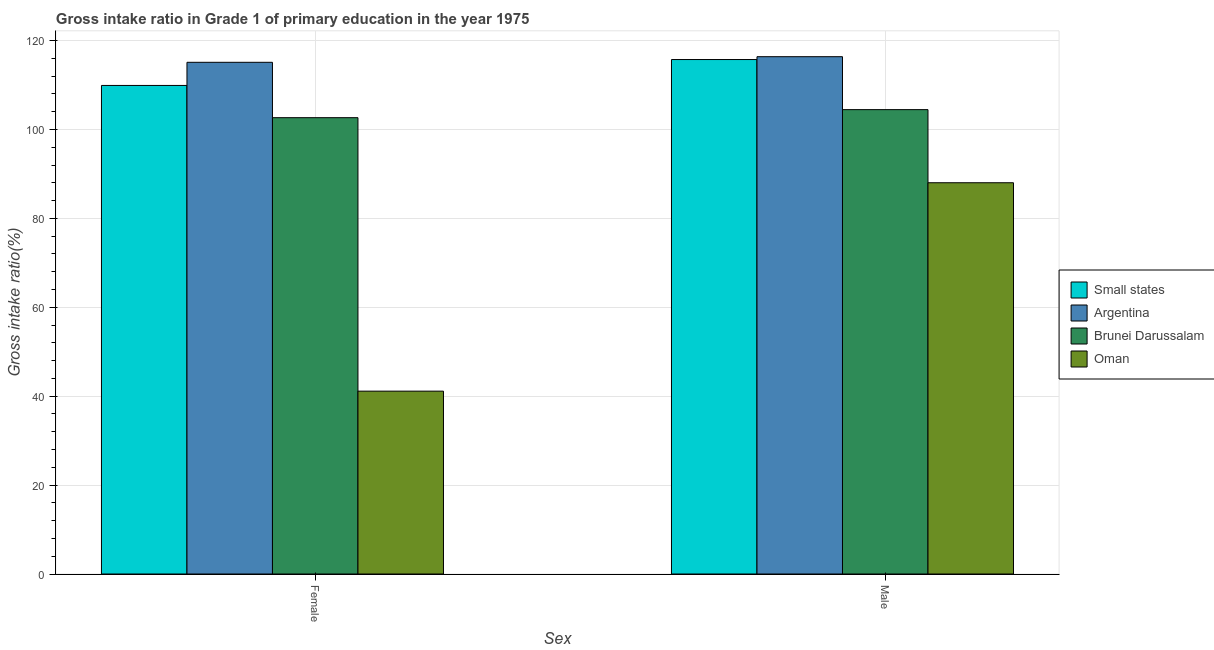How many different coloured bars are there?
Provide a succinct answer. 4. How many groups of bars are there?
Offer a terse response. 2. Are the number of bars per tick equal to the number of legend labels?
Offer a terse response. Yes. Are the number of bars on each tick of the X-axis equal?
Your response must be concise. Yes. How many bars are there on the 1st tick from the left?
Offer a terse response. 4. How many bars are there on the 1st tick from the right?
Keep it short and to the point. 4. What is the label of the 2nd group of bars from the left?
Your answer should be very brief. Male. What is the gross intake ratio(female) in Oman?
Ensure brevity in your answer.  41.14. Across all countries, what is the maximum gross intake ratio(female)?
Ensure brevity in your answer.  115.13. Across all countries, what is the minimum gross intake ratio(male)?
Give a very brief answer. 88.03. In which country was the gross intake ratio(male) minimum?
Offer a very short reply. Oman. What is the total gross intake ratio(male) in the graph?
Offer a terse response. 424.65. What is the difference between the gross intake ratio(female) in Oman and that in Argentina?
Your answer should be very brief. -73.98. What is the difference between the gross intake ratio(female) in Brunei Darussalam and the gross intake ratio(male) in Oman?
Keep it short and to the point. 14.64. What is the average gross intake ratio(male) per country?
Make the answer very short. 106.16. What is the difference between the gross intake ratio(male) and gross intake ratio(female) in Argentina?
Your response must be concise. 1.26. What is the ratio of the gross intake ratio(female) in Brunei Darussalam to that in Small states?
Offer a terse response. 0.93. Is the gross intake ratio(male) in Brunei Darussalam less than that in Small states?
Offer a very short reply. Yes. In how many countries, is the gross intake ratio(female) greater than the average gross intake ratio(female) taken over all countries?
Offer a terse response. 3. What does the 4th bar from the left in Male represents?
Your answer should be very brief. Oman. What does the 4th bar from the right in Male represents?
Your answer should be very brief. Small states. How many countries are there in the graph?
Your answer should be very brief. 4. Are the values on the major ticks of Y-axis written in scientific E-notation?
Give a very brief answer. No. Where does the legend appear in the graph?
Offer a terse response. Center right. What is the title of the graph?
Make the answer very short. Gross intake ratio in Grade 1 of primary education in the year 1975. Does "Myanmar" appear as one of the legend labels in the graph?
Provide a short and direct response. No. What is the label or title of the X-axis?
Your response must be concise. Sex. What is the label or title of the Y-axis?
Offer a terse response. Gross intake ratio(%). What is the Gross intake ratio(%) of Small states in Female?
Ensure brevity in your answer.  109.92. What is the Gross intake ratio(%) in Argentina in Female?
Give a very brief answer. 115.13. What is the Gross intake ratio(%) in Brunei Darussalam in Female?
Give a very brief answer. 102.67. What is the Gross intake ratio(%) of Oman in Female?
Provide a succinct answer. 41.14. What is the Gross intake ratio(%) in Small states in Male?
Offer a very short reply. 115.75. What is the Gross intake ratio(%) of Argentina in Male?
Your response must be concise. 116.39. What is the Gross intake ratio(%) of Brunei Darussalam in Male?
Make the answer very short. 104.48. What is the Gross intake ratio(%) of Oman in Male?
Make the answer very short. 88.03. Across all Sex, what is the maximum Gross intake ratio(%) of Small states?
Provide a short and direct response. 115.75. Across all Sex, what is the maximum Gross intake ratio(%) of Argentina?
Offer a terse response. 116.39. Across all Sex, what is the maximum Gross intake ratio(%) in Brunei Darussalam?
Give a very brief answer. 104.48. Across all Sex, what is the maximum Gross intake ratio(%) of Oman?
Make the answer very short. 88.03. Across all Sex, what is the minimum Gross intake ratio(%) in Small states?
Your answer should be compact. 109.92. Across all Sex, what is the minimum Gross intake ratio(%) of Argentina?
Ensure brevity in your answer.  115.13. Across all Sex, what is the minimum Gross intake ratio(%) of Brunei Darussalam?
Your response must be concise. 102.67. Across all Sex, what is the minimum Gross intake ratio(%) of Oman?
Your answer should be very brief. 41.14. What is the total Gross intake ratio(%) in Small states in the graph?
Your response must be concise. 225.67. What is the total Gross intake ratio(%) of Argentina in the graph?
Provide a short and direct response. 231.52. What is the total Gross intake ratio(%) of Brunei Darussalam in the graph?
Your response must be concise. 207.15. What is the total Gross intake ratio(%) of Oman in the graph?
Ensure brevity in your answer.  129.17. What is the difference between the Gross intake ratio(%) of Small states in Female and that in Male?
Ensure brevity in your answer.  -5.83. What is the difference between the Gross intake ratio(%) in Argentina in Female and that in Male?
Keep it short and to the point. -1.26. What is the difference between the Gross intake ratio(%) of Brunei Darussalam in Female and that in Male?
Offer a terse response. -1.81. What is the difference between the Gross intake ratio(%) in Oman in Female and that in Male?
Provide a succinct answer. -46.89. What is the difference between the Gross intake ratio(%) in Small states in Female and the Gross intake ratio(%) in Argentina in Male?
Offer a very short reply. -6.47. What is the difference between the Gross intake ratio(%) in Small states in Female and the Gross intake ratio(%) in Brunei Darussalam in Male?
Keep it short and to the point. 5.44. What is the difference between the Gross intake ratio(%) of Small states in Female and the Gross intake ratio(%) of Oman in Male?
Your answer should be compact. 21.89. What is the difference between the Gross intake ratio(%) in Argentina in Female and the Gross intake ratio(%) in Brunei Darussalam in Male?
Offer a terse response. 10.65. What is the difference between the Gross intake ratio(%) of Argentina in Female and the Gross intake ratio(%) of Oman in Male?
Keep it short and to the point. 27.1. What is the difference between the Gross intake ratio(%) of Brunei Darussalam in Female and the Gross intake ratio(%) of Oman in Male?
Keep it short and to the point. 14.64. What is the average Gross intake ratio(%) in Small states per Sex?
Provide a short and direct response. 112.83. What is the average Gross intake ratio(%) in Argentina per Sex?
Provide a succinct answer. 115.76. What is the average Gross intake ratio(%) in Brunei Darussalam per Sex?
Offer a terse response. 103.57. What is the average Gross intake ratio(%) in Oman per Sex?
Offer a very short reply. 64.58. What is the difference between the Gross intake ratio(%) in Small states and Gross intake ratio(%) in Argentina in Female?
Ensure brevity in your answer.  -5.21. What is the difference between the Gross intake ratio(%) of Small states and Gross intake ratio(%) of Brunei Darussalam in Female?
Offer a very short reply. 7.25. What is the difference between the Gross intake ratio(%) in Small states and Gross intake ratio(%) in Oman in Female?
Keep it short and to the point. 68.78. What is the difference between the Gross intake ratio(%) in Argentina and Gross intake ratio(%) in Brunei Darussalam in Female?
Provide a succinct answer. 12.46. What is the difference between the Gross intake ratio(%) in Argentina and Gross intake ratio(%) in Oman in Female?
Provide a succinct answer. 73.98. What is the difference between the Gross intake ratio(%) of Brunei Darussalam and Gross intake ratio(%) of Oman in Female?
Offer a very short reply. 61.53. What is the difference between the Gross intake ratio(%) of Small states and Gross intake ratio(%) of Argentina in Male?
Provide a short and direct response. -0.64. What is the difference between the Gross intake ratio(%) of Small states and Gross intake ratio(%) of Brunei Darussalam in Male?
Keep it short and to the point. 11.27. What is the difference between the Gross intake ratio(%) of Small states and Gross intake ratio(%) of Oman in Male?
Provide a succinct answer. 27.72. What is the difference between the Gross intake ratio(%) of Argentina and Gross intake ratio(%) of Brunei Darussalam in Male?
Offer a terse response. 11.91. What is the difference between the Gross intake ratio(%) of Argentina and Gross intake ratio(%) of Oman in Male?
Ensure brevity in your answer.  28.36. What is the difference between the Gross intake ratio(%) of Brunei Darussalam and Gross intake ratio(%) of Oman in Male?
Offer a very short reply. 16.45. What is the ratio of the Gross intake ratio(%) of Small states in Female to that in Male?
Provide a short and direct response. 0.95. What is the ratio of the Gross intake ratio(%) in Argentina in Female to that in Male?
Make the answer very short. 0.99. What is the ratio of the Gross intake ratio(%) of Brunei Darussalam in Female to that in Male?
Your response must be concise. 0.98. What is the ratio of the Gross intake ratio(%) of Oman in Female to that in Male?
Offer a very short reply. 0.47. What is the difference between the highest and the second highest Gross intake ratio(%) of Small states?
Provide a succinct answer. 5.83. What is the difference between the highest and the second highest Gross intake ratio(%) of Argentina?
Provide a short and direct response. 1.26. What is the difference between the highest and the second highest Gross intake ratio(%) of Brunei Darussalam?
Make the answer very short. 1.81. What is the difference between the highest and the second highest Gross intake ratio(%) in Oman?
Your answer should be very brief. 46.89. What is the difference between the highest and the lowest Gross intake ratio(%) of Small states?
Keep it short and to the point. 5.83. What is the difference between the highest and the lowest Gross intake ratio(%) in Argentina?
Give a very brief answer. 1.26. What is the difference between the highest and the lowest Gross intake ratio(%) of Brunei Darussalam?
Keep it short and to the point. 1.81. What is the difference between the highest and the lowest Gross intake ratio(%) of Oman?
Your response must be concise. 46.89. 